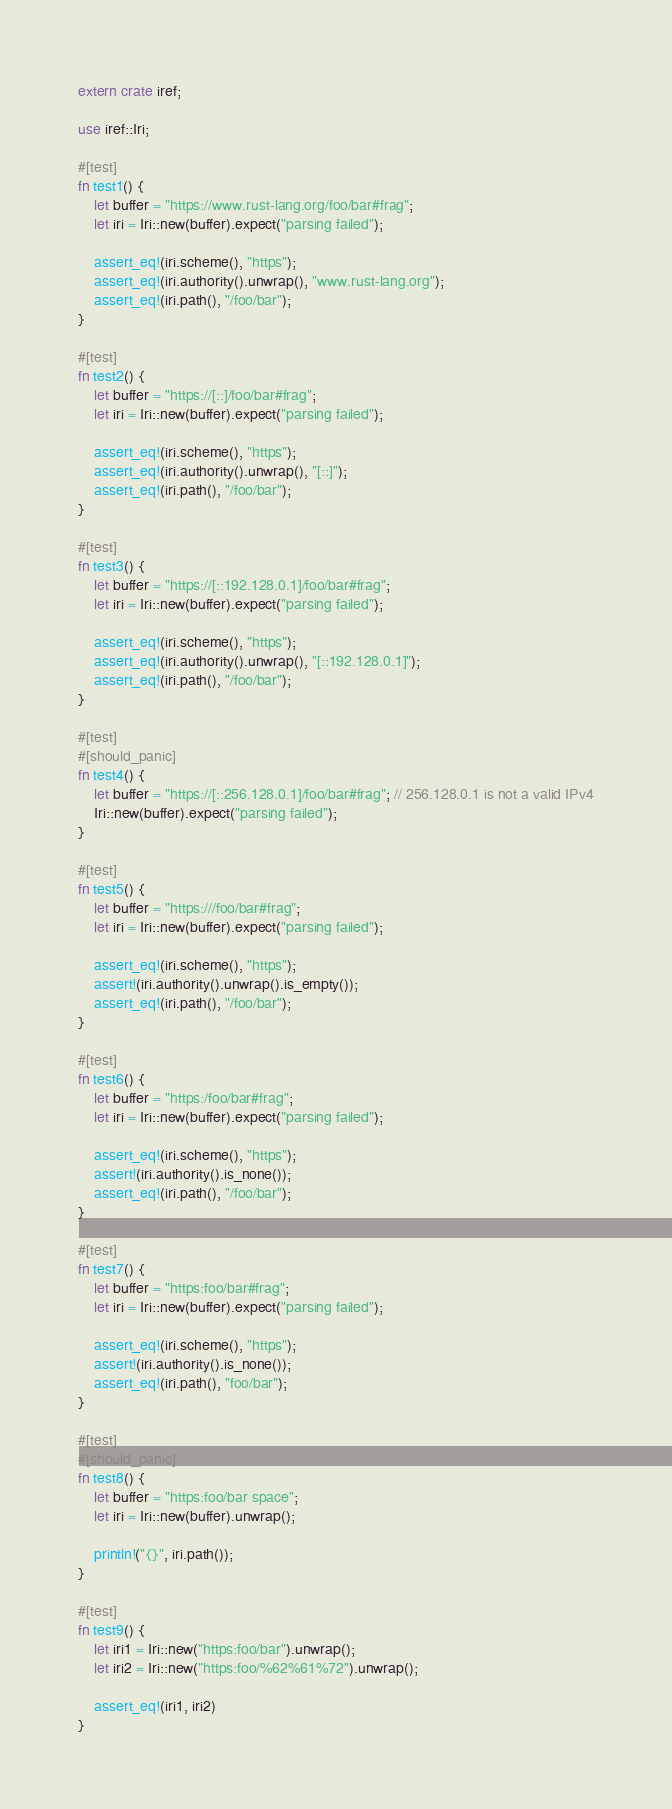<code> <loc_0><loc_0><loc_500><loc_500><_Rust_>extern crate iref;

use iref::Iri;

#[test]
fn test1() {
	let buffer = "https://www.rust-lang.org/foo/bar#frag";
	let iri = Iri::new(buffer).expect("parsing failed");

	assert_eq!(iri.scheme(), "https");
	assert_eq!(iri.authority().unwrap(), "www.rust-lang.org");
	assert_eq!(iri.path(), "/foo/bar");
}

#[test]
fn test2() {
	let buffer = "https://[::]/foo/bar#frag";
	let iri = Iri::new(buffer).expect("parsing failed");

	assert_eq!(iri.scheme(), "https");
	assert_eq!(iri.authority().unwrap(), "[::]");
	assert_eq!(iri.path(), "/foo/bar");
}

#[test]
fn test3() {
	let buffer = "https://[::192.128.0.1]/foo/bar#frag";
	let iri = Iri::new(buffer).expect("parsing failed");

	assert_eq!(iri.scheme(), "https");
	assert_eq!(iri.authority().unwrap(), "[::192.128.0.1]");
	assert_eq!(iri.path(), "/foo/bar");
}

#[test]
#[should_panic]
fn test4() {
	let buffer = "https://[::256.128.0.1]/foo/bar#frag"; // 256.128.0.1 is not a valid IPv4
	Iri::new(buffer).expect("parsing failed");
}

#[test]
fn test5() {
	let buffer = "https:///foo/bar#frag";
	let iri = Iri::new(buffer).expect("parsing failed");

	assert_eq!(iri.scheme(), "https");
	assert!(iri.authority().unwrap().is_empty());
	assert_eq!(iri.path(), "/foo/bar");
}

#[test]
fn test6() {
	let buffer = "https:/foo/bar#frag";
	let iri = Iri::new(buffer).expect("parsing failed");

	assert_eq!(iri.scheme(), "https");
	assert!(iri.authority().is_none());
	assert_eq!(iri.path(), "/foo/bar");
}

#[test]
fn test7() {
	let buffer = "https:foo/bar#frag";
	let iri = Iri::new(buffer).expect("parsing failed");

	assert_eq!(iri.scheme(), "https");
	assert!(iri.authority().is_none());
	assert_eq!(iri.path(), "foo/bar");
}

#[test]
#[should_panic]
fn test8() {
	let buffer = "https:foo/bar space";
	let iri = Iri::new(buffer).unwrap();

	println!("{}", iri.path());
}

#[test]
fn test9() {
	let iri1 = Iri::new("https:foo/bar").unwrap();
	let iri2 = Iri::new("https:foo/%62%61%72").unwrap();

	assert_eq!(iri1, iri2)
}
</code> 